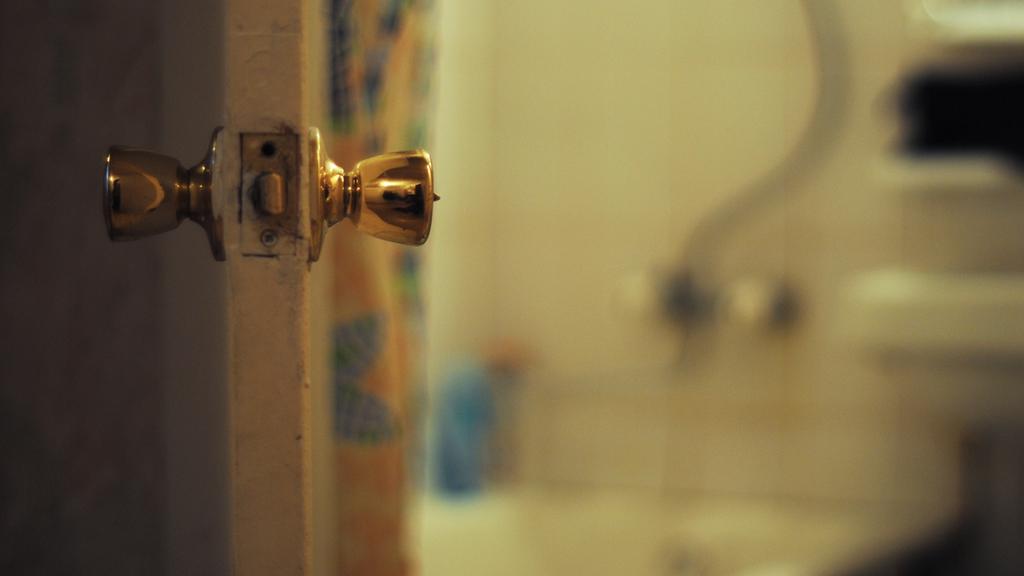In one or two sentences, can you explain what this image depicts? in this image there is one door as we can see at left side of this image. 